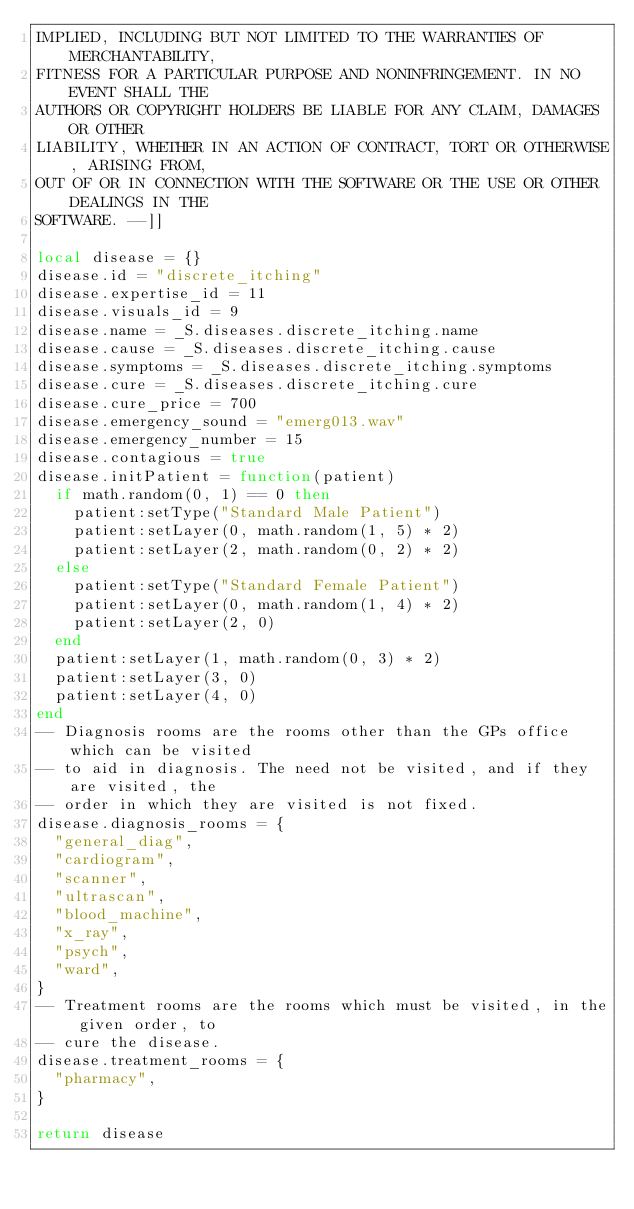<code> <loc_0><loc_0><loc_500><loc_500><_Lua_>IMPLIED, INCLUDING BUT NOT LIMITED TO THE WARRANTIES OF MERCHANTABILITY,
FITNESS FOR A PARTICULAR PURPOSE AND NONINFRINGEMENT. IN NO EVENT SHALL THE
AUTHORS OR COPYRIGHT HOLDERS BE LIABLE FOR ANY CLAIM, DAMAGES OR OTHER
LIABILITY, WHETHER IN AN ACTION OF CONTRACT, TORT OR OTHERWISE, ARISING FROM,
OUT OF OR IN CONNECTION WITH THE SOFTWARE OR THE USE OR OTHER DEALINGS IN THE
SOFTWARE. --]]

local disease = {}
disease.id = "discrete_itching"
disease.expertise_id = 11
disease.visuals_id = 9
disease.name = _S.diseases.discrete_itching.name
disease.cause = _S.diseases.discrete_itching.cause
disease.symptoms = _S.diseases.discrete_itching.symptoms
disease.cure = _S.diseases.discrete_itching.cure
disease.cure_price = 700
disease.emergency_sound = "emerg013.wav"
disease.emergency_number = 15
disease.contagious = true
disease.initPatient = function(patient)
  if math.random(0, 1) == 0 then
    patient:setType("Standard Male Patient")
    patient:setLayer(0, math.random(1, 5) * 2)
    patient:setLayer(2, math.random(0, 2) * 2)
  else
    patient:setType("Standard Female Patient")
    patient:setLayer(0, math.random(1, 4) * 2)
    patient:setLayer(2, 0)
  end
  patient:setLayer(1, math.random(0, 3) * 2)
  patient:setLayer(3, 0)
  patient:setLayer(4, 0)
end
-- Diagnosis rooms are the rooms other than the GPs office which can be visited
-- to aid in diagnosis. The need not be visited, and if they are visited, the
-- order in which they are visited is not fixed.
disease.diagnosis_rooms = {
  "general_diag",
  "cardiogram",
  "scanner",
  "ultrascan",
  "blood_machine",
  "x_ray",
  "psych",
  "ward",
}
-- Treatment rooms are the rooms which must be visited, in the given order, to
-- cure the disease.
disease.treatment_rooms = {
  "pharmacy",
}

return disease
</code> 